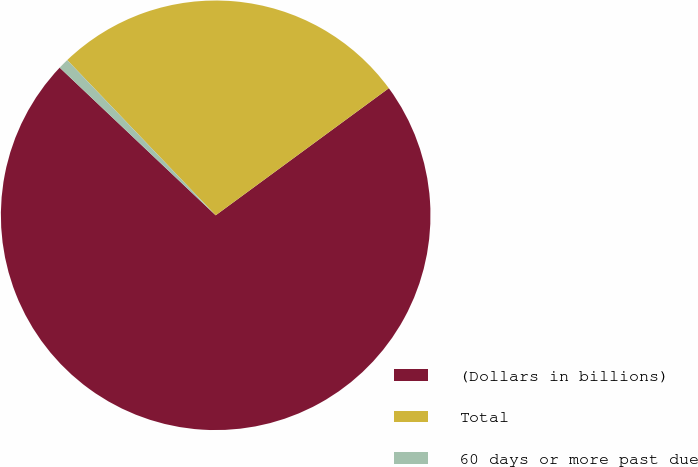Convert chart. <chart><loc_0><loc_0><loc_500><loc_500><pie_chart><fcel>(Dollars in billions)<fcel>Total<fcel>60 days or more past due<nl><fcel>72.14%<fcel>27.07%<fcel>0.79%<nl></chart> 